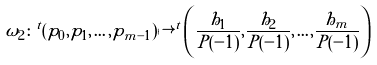<formula> <loc_0><loc_0><loc_500><loc_500>\omega _ { 2 } \colon ^ { t } ( p _ { 0 } , p _ { 1 } , \dots , p _ { m - 1 } ) \mapsto ^ { t } \left ( \frac { h _ { 1 } } { P ( - 1 ) } , \frac { h _ { 2 } } { P ( - 1 ) } , \dots , \frac { h _ { m } } { P ( - 1 ) } \right )</formula> 